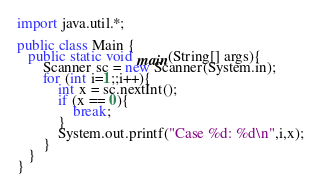Convert code to text. <code><loc_0><loc_0><loc_500><loc_500><_Java_>import java.util.*;

public class Main {
   public static void main(String[] args){
	   Scanner sc = new Scanner(System.in);
	   for (int i=1;;i++){
		   int x = sc.nextInt();
		   if (x == 0){
			   break;
		   }
		   System.out.printf("Case %d: %d\n",i,x);
	   }
   }
}</code> 